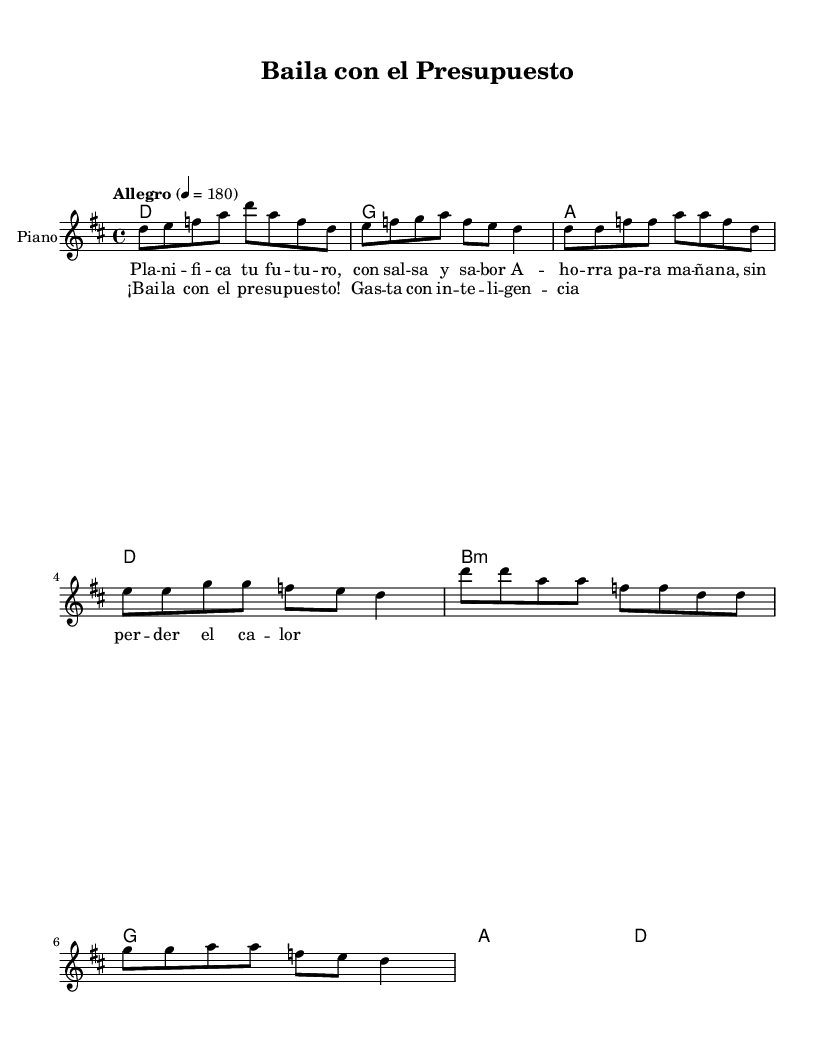What is the key signature of this music? The key signature is D major, which has two sharps: F# and C#. This can be identified by the key signature symbol found at the beginning of the staff.
Answer: D major What is the time signature of this music? The time signature is 4/4, indicated by the two numbers found at the beginning of the staff. The top number '4' represents four beats in a measure, and the bottom '4' indicates that each beat is a quarter note.
Answer: 4/4 What is the tempo marking of this piece? The tempo marking is "Allegro," which typically indicates a fast tempo. The number 180 following it specifies the beats per minute, allowing the performer to understand the intended speed of the piece.
Answer: Allegro How many measures are in the verse? There are four measures in the verse, as indicated by the groupings of notes in each line. Each line of the verse corresponds to a specific musical measure.
Answer: Four What is the primary theme of the chorus lyrics? The chorus lyrics emphasize dancing and budgeting, specifically encouraging the listener to dance with a budget and spend wisely. The repeated phrases convey a sense of urgency regarding financial responsibility while celebrating enjoyment in life.
Answer: Dance with the budget What is the chord in the first measure? The chord in the first measure is D major. This can be confirmed by analyzing the chord symbols written above the staff, where 'd' corresponds to D major chord being played.
Answer: D major What rhythmic pattern is used prominently in the melody? The rhythmic pattern primarily features eighth notes followed by quarter notes, creating a lively and syncopated rhythm typical of salsa music. This pattern can be observed throughout the melody.
Answer: Eighth notes and quarter notes 